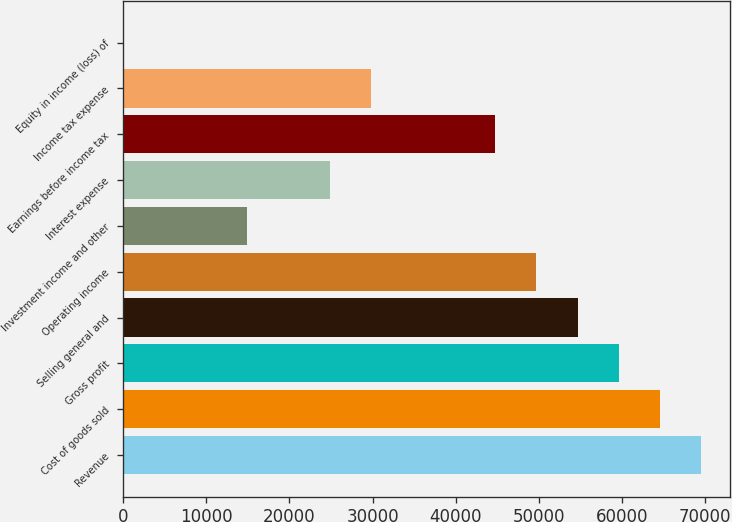Convert chart. <chart><loc_0><loc_0><loc_500><loc_500><bar_chart><fcel>Revenue<fcel>Cost of goods sold<fcel>Gross profit<fcel>Selling general and<fcel>Operating income<fcel>Investment income and other<fcel>Interest expense<fcel>Earnings before income tax<fcel>Income tax expense<fcel>Equity in income (loss) of<nl><fcel>69571.2<fcel>64601.9<fcel>59632.6<fcel>54663.3<fcel>49694<fcel>14908.9<fcel>24847.5<fcel>44724.7<fcel>29816.8<fcel>1<nl></chart> 